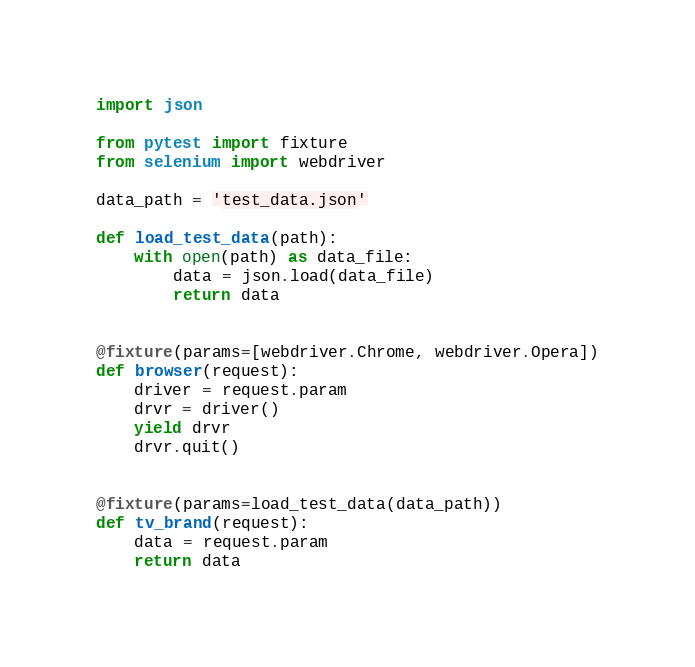Convert code to text. <code><loc_0><loc_0><loc_500><loc_500><_Python_>import json

from pytest import fixture
from selenium import webdriver

data_path = 'test_data.json'

def load_test_data(path):
    with open(path) as data_file:
        data = json.load(data_file)
        return data        


@fixture(params=[webdriver.Chrome, webdriver.Opera])
def browser(request):
    driver = request.param
    drvr = driver()
    yield drvr
    drvr.quit()
    
    
@fixture(params=load_test_data(data_path))
def tv_brand(request):
    data = request.param
    return data</code> 